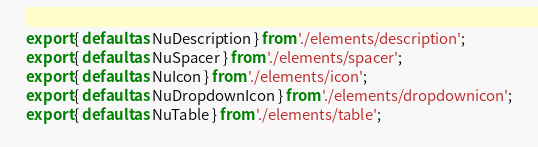<code> <loc_0><loc_0><loc_500><loc_500><_JavaScript_>export { default as NuDescription } from './elements/description';
export { default as NuSpacer } from './elements/spacer';
export { default as NuIcon } from './elements/icon';
export { default as NuDropdownIcon } from './elements/dropdownicon';
export { default as NuTable } from './elements/table';</code> 